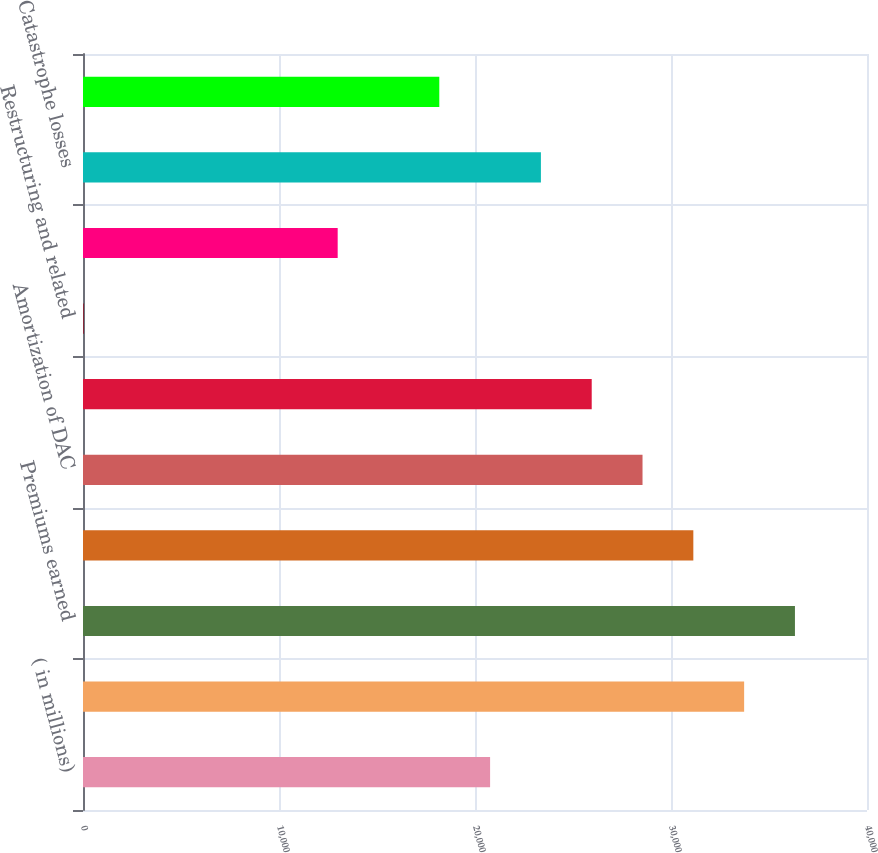Convert chart to OTSL. <chart><loc_0><loc_0><loc_500><loc_500><bar_chart><fcel>( in millions)<fcel>Premiums written<fcel>Premiums earned<fcel>Claims and claims expense<fcel>Amortization of DAC<fcel>Other costs and expenses<fcel>Restructuring and related<fcel>Underwriting income (loss)<fcel>Catastrophe losses<fcel>Standard auto<nl><fcel>20770.6<fcel>33731.6<fcel>36323.8<fcel>31139.4<fcel>28547.2<fcel>25955<fcel>33<fcel>12994<fcel>23362.8<fcel>18178.4<nl></chart> 